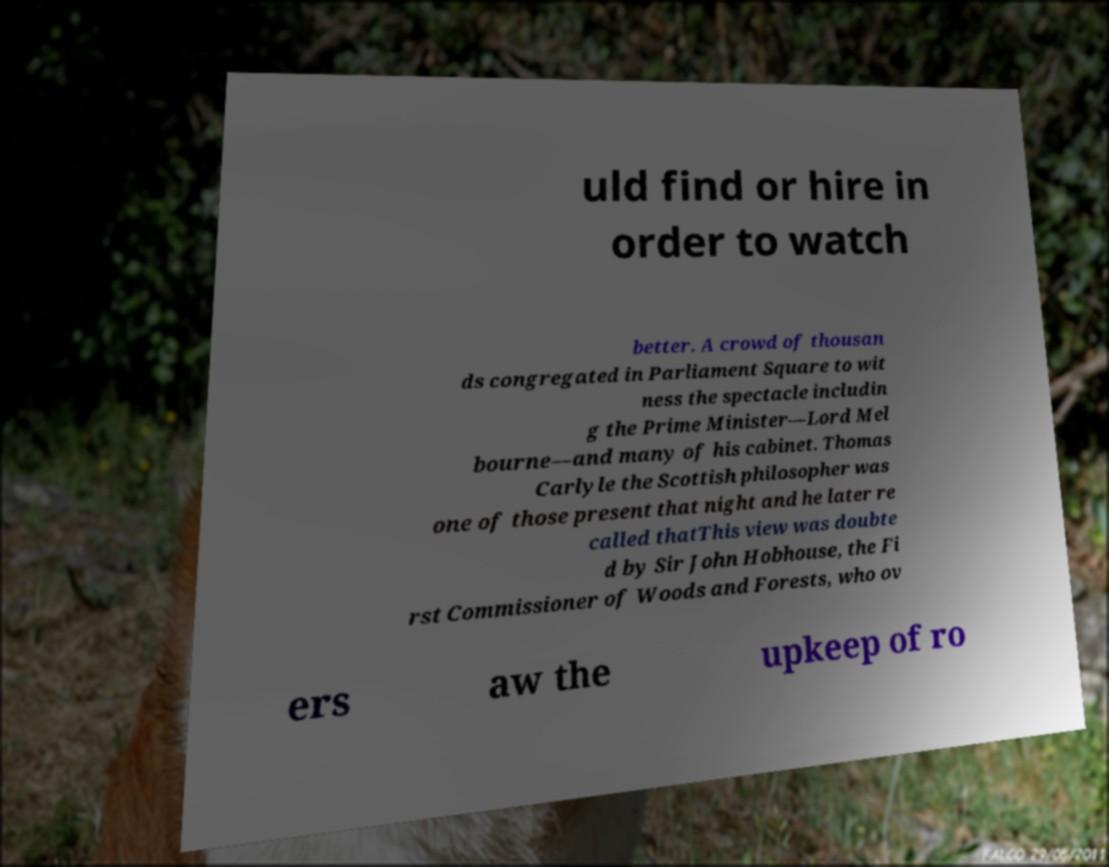Please identify and transcribe the text found in this image. uld find or hire in order to watch better. A crowd of thousan ds congregated in Parliament Square to wit ness the spectacle includin g the Prime Minister—Lord Mel bourne—and many of his cabinet. Thomas Carlyle the Scottish philosopher was one of those present that night and he later re called thatThis view was doubte d by Sir John Hobhouse, the Fi rst Commissioner of Woods and Forests, who ov ers aw the upkeep of ro 